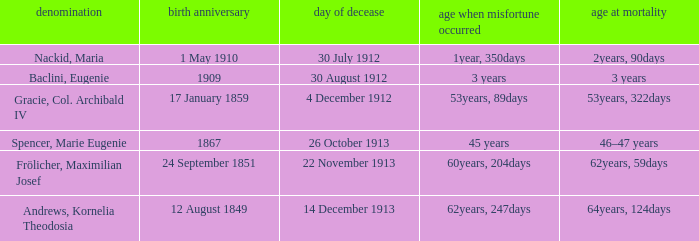When did the person born 24 September 1851 pass away? 22 November 1913. 